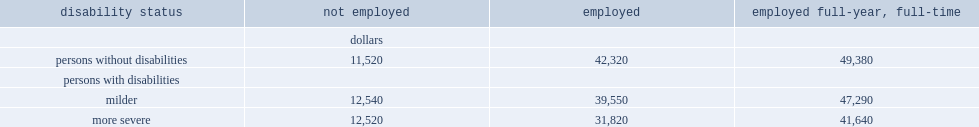Which disability status had lower median incomes? employed persons with milder disabilities or thosse without disabilities? Milder. 